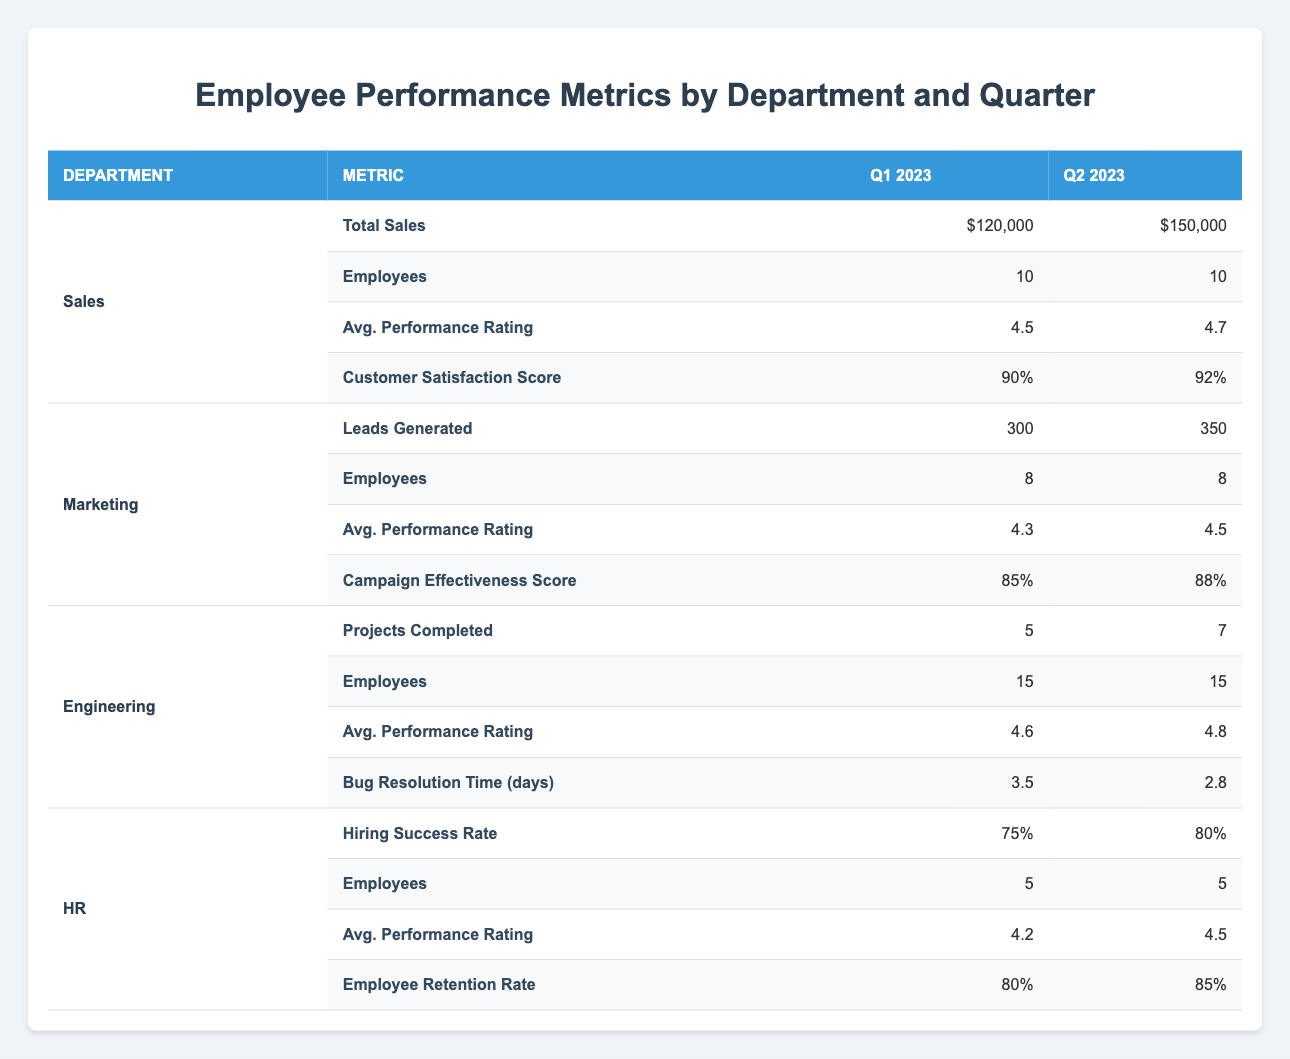What were the total sales in Q2 2023 for the Sales department? The Sales department reported total sales of $150,000 in Q2 2023. This value can be found directly in the column for Q2 2023 under the Sales department.
Answer: $150,000 Which department had the highest average performance rating in Q1 2023? In Q1 2023, the Engineering department had the highest average performance rating of 4.6. This can be determined by comparing the average performance ratings across all departments for that quarter.
Answer: Engineering What is the percentage increase in total sales from Q1 to Q2 2023 in the Sales department? The total sales in Q1 2023 were $120,000 and in Q2 2023 they were $150,000. The increase is calculated as follows: ($150,000 - $120,000) / $120,000 * 100 = 25%. This shows the growth rate from Q1 to Q2.
Answer: 25% How many employees are there in total across all departments in Q1 2023? In Q1 2023, the employee counts are as follows: Sales (10), Marketing (8), Engineering (15), HR (5). Adding these, we get a total of 10 + 8 + 15 + 5 = 38 employees across all departments.
Answer: 38 Is the customer satisfaction score in Q2 2023 higher than 90% in the Sales department? The customer satisfaction score for the Sales department in Q2 2023 is 92%, which is indeed higher than 90%. This is answered by directly comparing the value listed for Q2 2023 in the table.
Answer: Yes What is the average employee retention rate for HR between Q1 and Q2 2023? The employee retention rates are 80% in Q1 and 85% in Q2. The average can be calculated as (80% + 85%) / 2 = 82.5%. This provides the overall average retention rate for the HR department over the two quarters.
Answer: 82.5% Did the Engineering department complete more projects in Q2 2023 than in Q1 2023? The Engineering department completed 5 projects in Q1 2023 and 7 projects in Q2 2023. Since 7 is greater than 5, the Engineering department indeed completed more projects in Q2.
Answer: Yes What was the leads generated difference between Q1 2023 and Q2 2023 for the Marketing department? In Q1 2023, the Marketing department generated 300 leads, while in Q2 2023 it generated 350 leads. The difference is calculated as 350 - 300 = 50 leads. This reveals the growth in lead generation from Q1 to Q2.
Answer: 50 